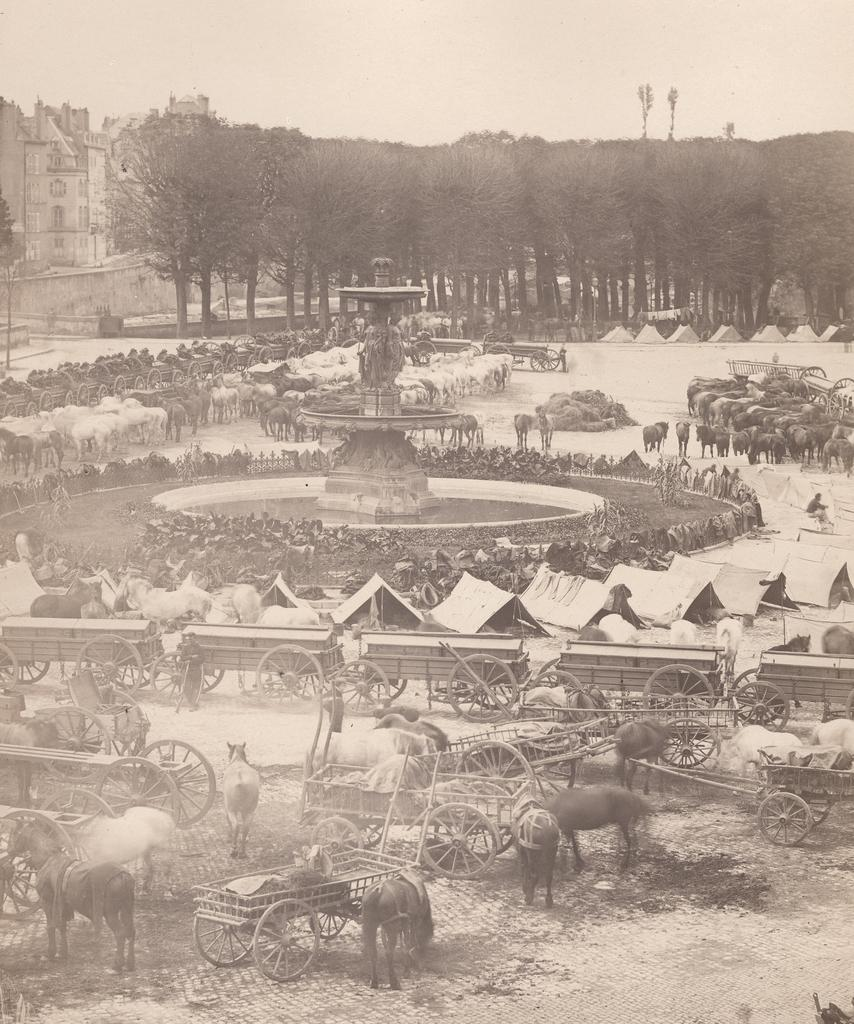What type of structures can be seen in the image? There are buildings in the image. What natural elements are present in the image? There are trees in the image. What living creatures can be seen in the image? There are animals in the image. What type of transportation is visible in the image? There are carts in the image. What type of water feature is present in the image? There is a fountain in the image. What type of artwork is present in the image? There are sculptures in thes in the image. What part of the natural environment is visible in the image? The sky is visible in the image. What type of sail can be seen on the animals in the image? There are no sails present in the image, and the animals are not depicted as having sails. What is the income of the person who created the sculptures in the image? The income of the person who created the sculptures is not mentioned or visible in the image. 